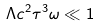Convert formula to latex. <formula><loc_0><loc_0><loc_500><loc_500>\Lambda c ^ { 2 } \tau ^ { 3 } \omega \ll 1</formula> 